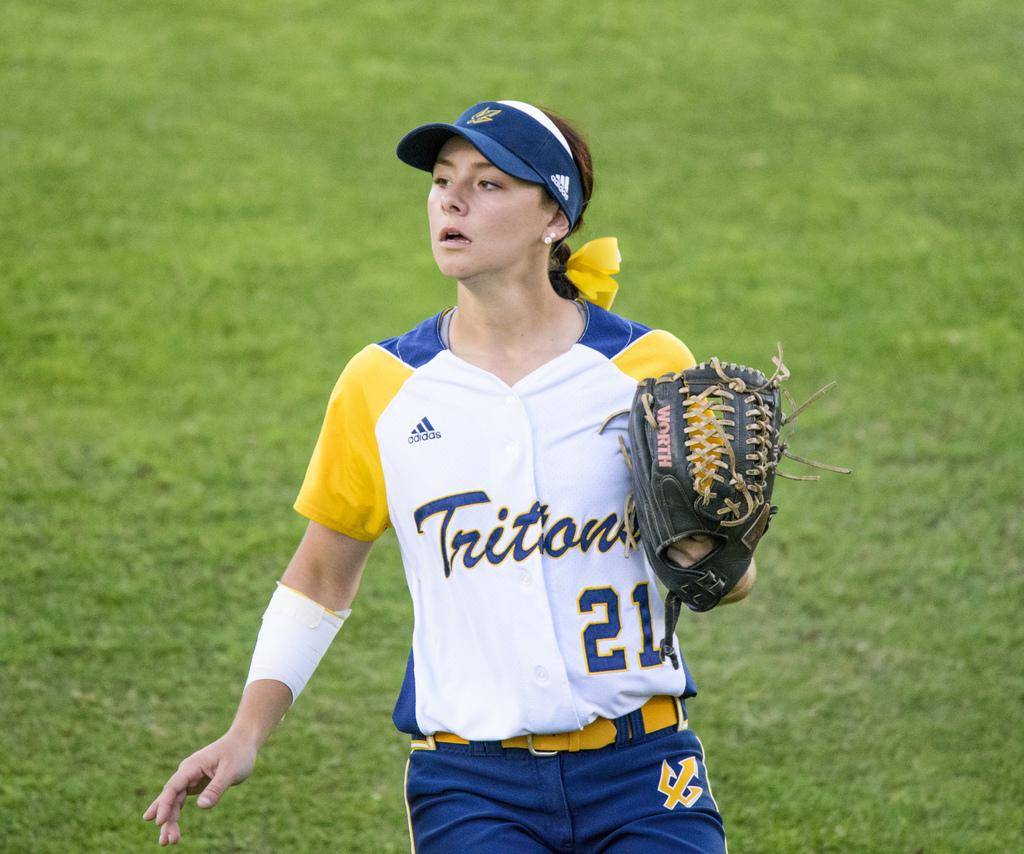What is the of the team on her shirt?
Make the answer very short. Tritons. Which athletic apparel company is advertised on the girl's jersey?
Your response must be concise. Adidas. 